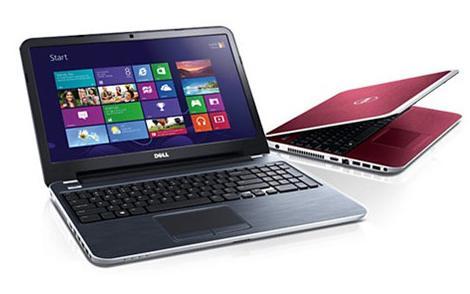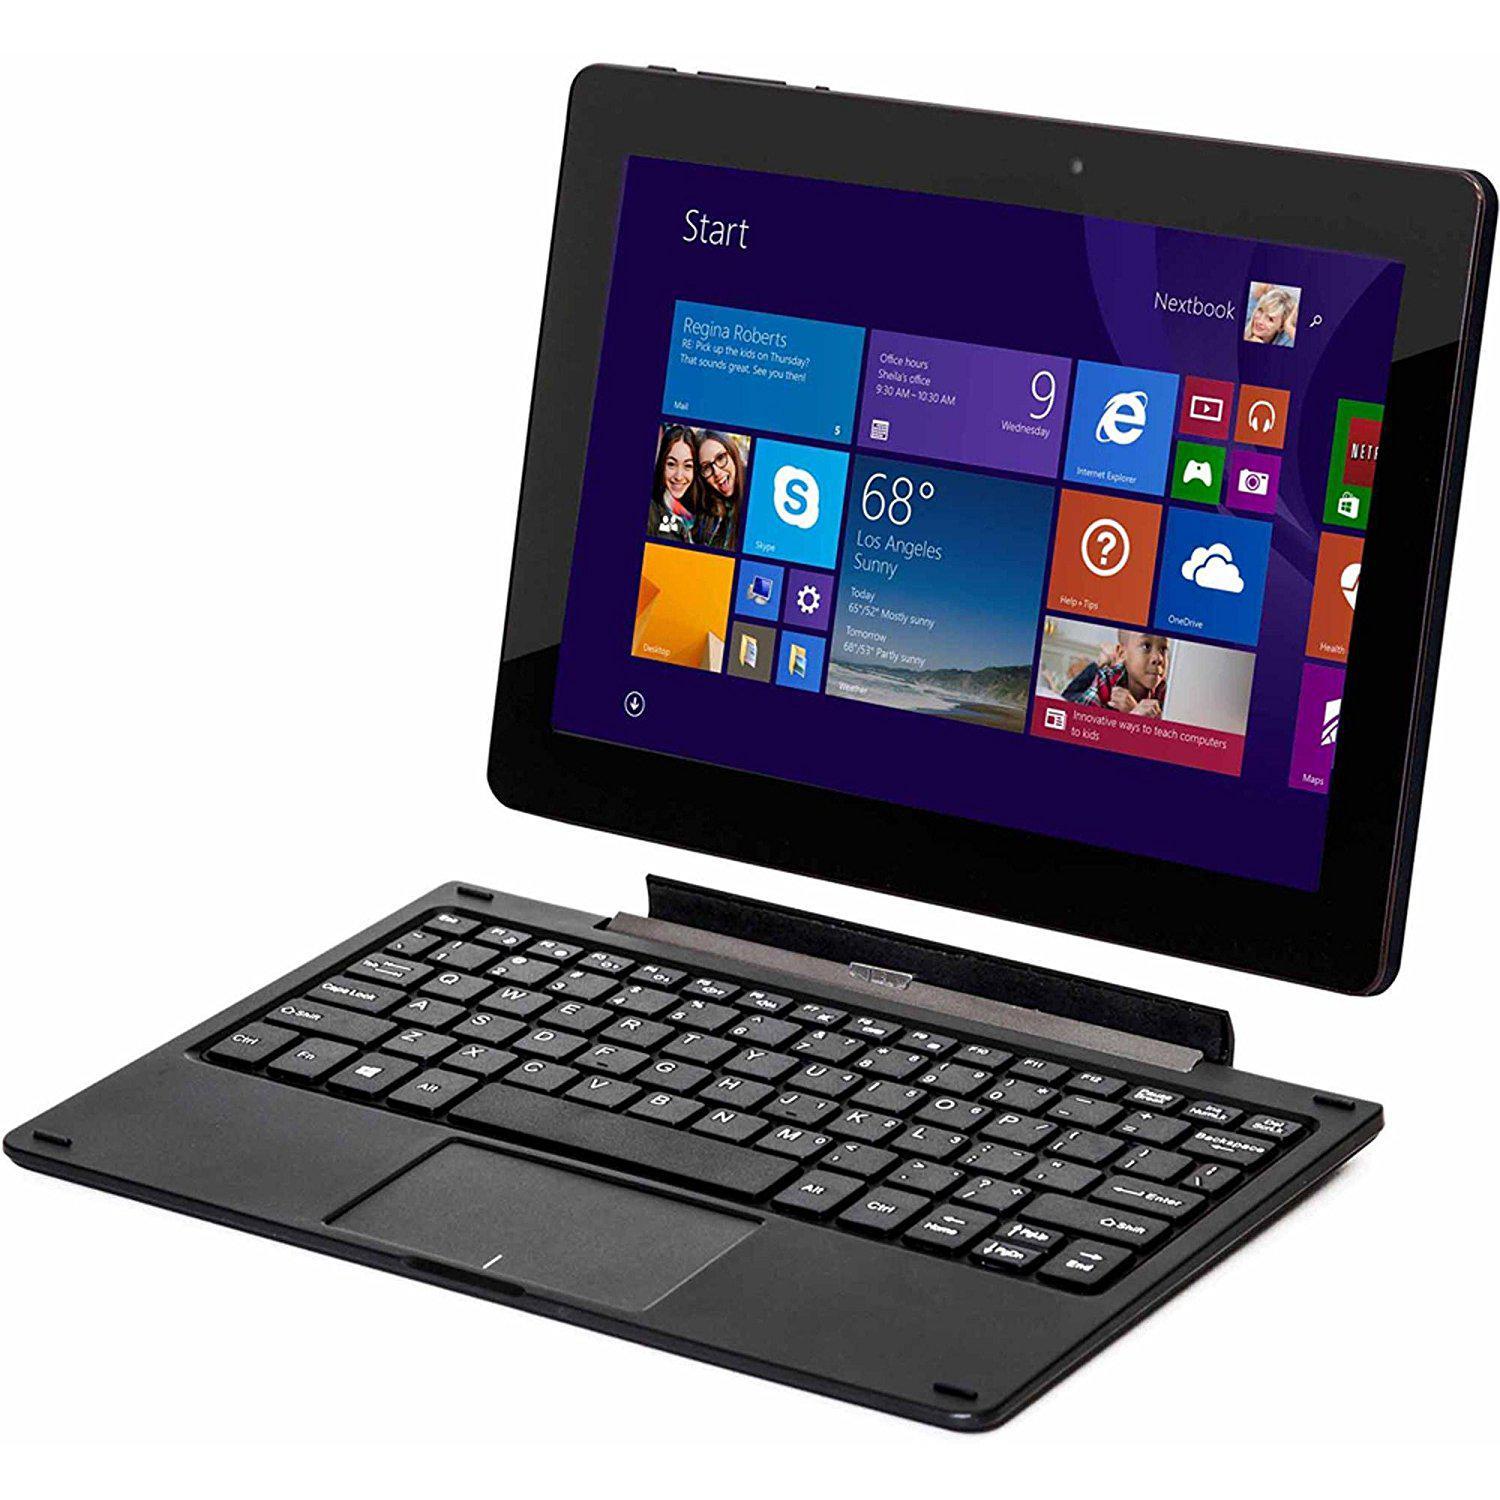The first image is the image on the left, the second image is the image on the right. Assess this claim about the two images: "The laptops face the same direction.". Correct or not? Answer yes or no. No. 